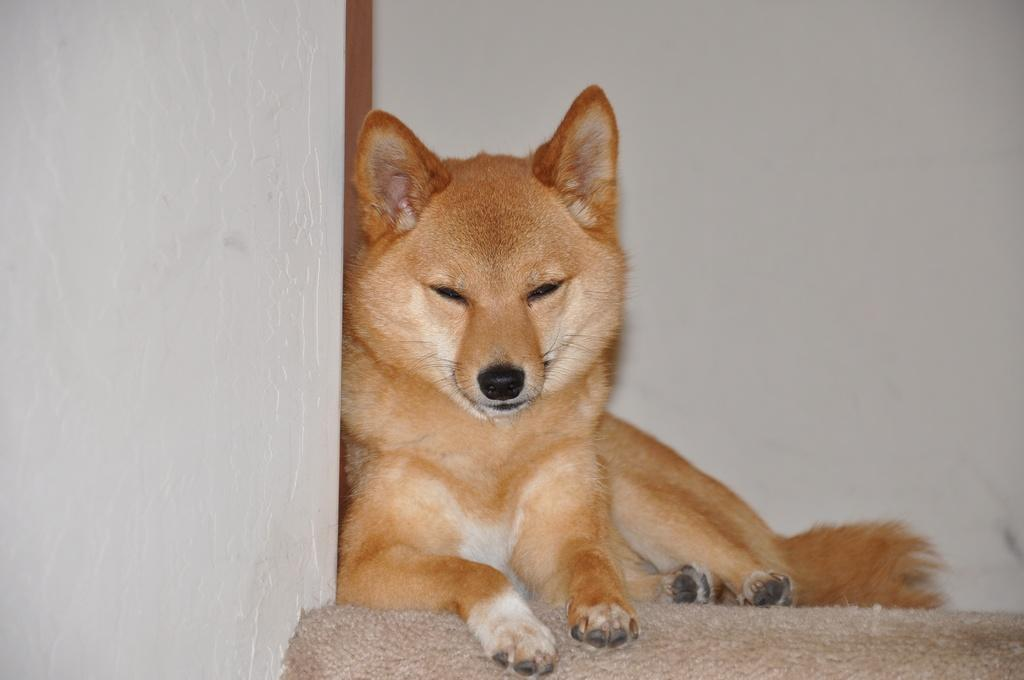What type of animal is in the image? There is a brown dog in the image. What is the dog doing in the image? The dog is resting on a mat. What can be seen in the background of the image? There is a wall in the background of the image. How many chickens are in the flock that is visible in the image? There are no chickens or flock present in the image; it features a brown dog resting on a mat with a wall in the background. 